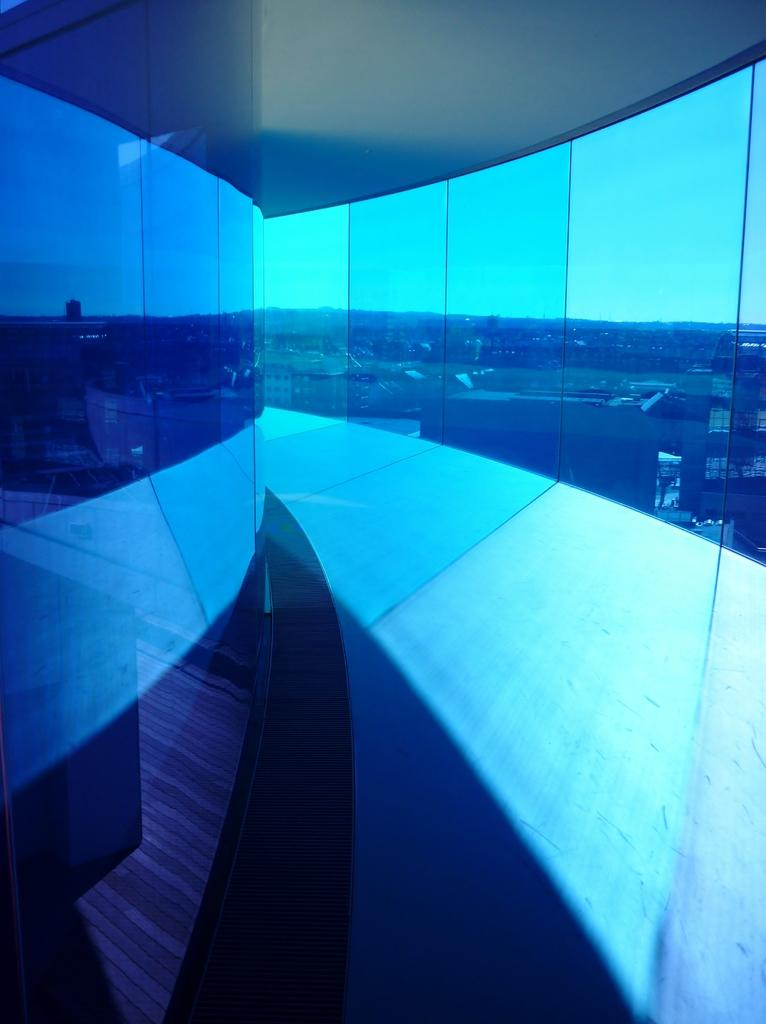What type of wall is present in the image? There is a glass wall in the image. What kind of apparatus is used to catch the jellyfish in the image? There are no jellyfish or apparatus present in the image; it only features a glass wall. What type of fowl can be seen perched on the glass wall in the image? There are no fowl present in the image; it only features a glass wall. 